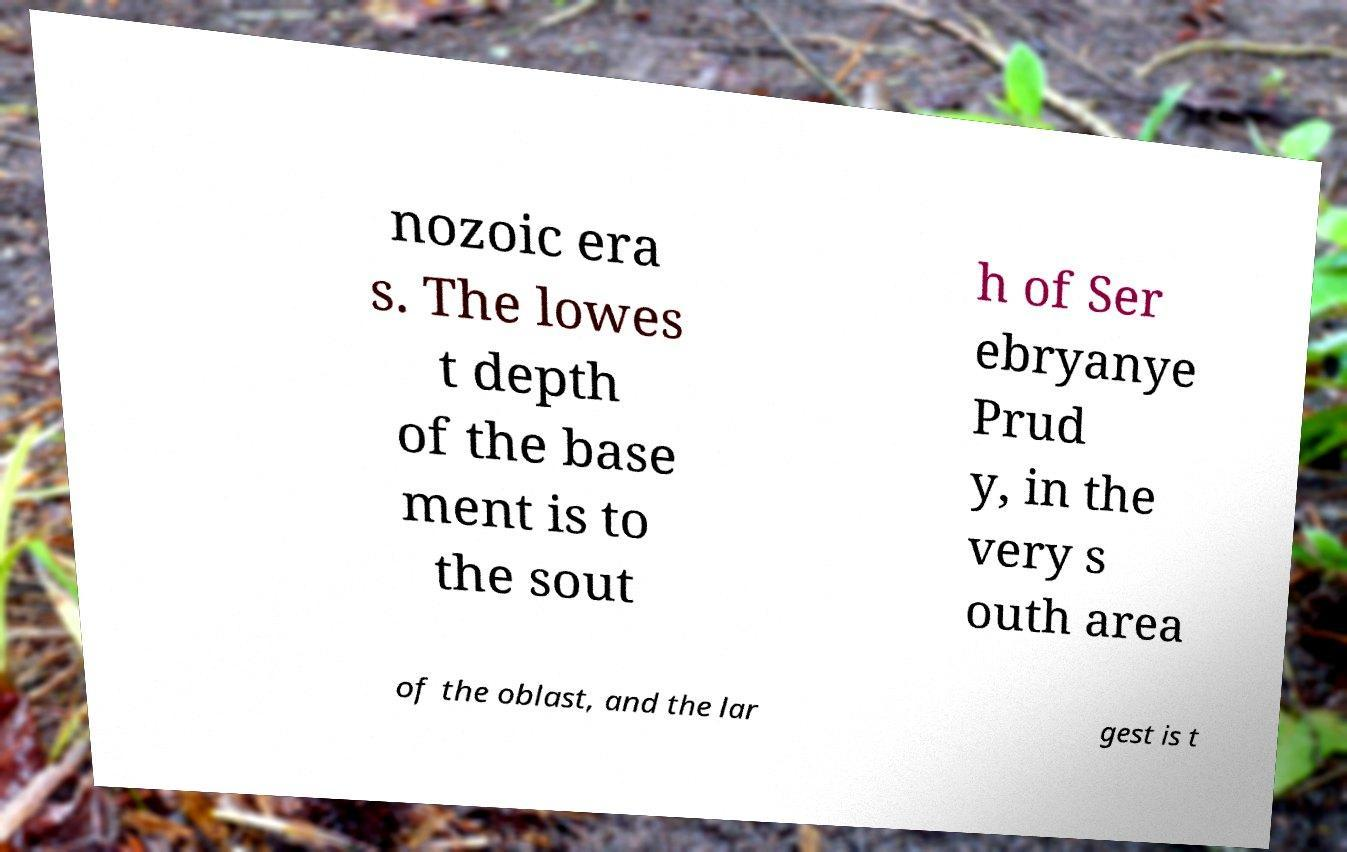Could you extract and type out the text from this image? nozoic era s. The lowes t depth of the base ment is to the sout h of Ser ebryanye Prud y, in the very s outh area of the oblast, and the lar gest is t 